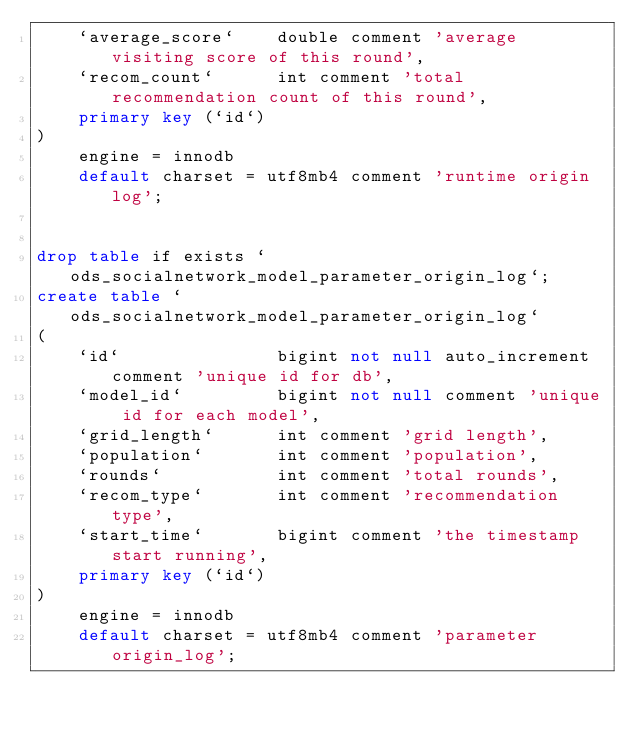<code> <loc_0><loc_0><loc_500><loc_500><_SQL_>    `average_score`    double comment 'average visiting score of this round',
    `recom_count`      int comment 'total recommendation count of this round',
    primary key (`id`)
)
    engine = innodb
    default charset = utf8mb4 comment 'runtime origin log';


drop table if exists `ods_socialnetwork_model_parameter_origin_log`;
create table `ods_socialnetwork_model_parameter_origin_log`
(
    `id`               bigint not null auto_increment comment 'unique id for db',
    `model_id`         bigint not null comment 'unique id for each model',
    `grid_length`      int comment 'grid length',
    `population`       int comment 'population',
    `rounds`           int comment 'total rounds',
    `recom_type`       int comment 'recommendation type',
    `start_time`       bigint comment 'the timestamp start running',
    primary key (`id`)
)
    engine = innodb
    default charset = utf8mb4 comment 'parameter origin_log';
</code> 